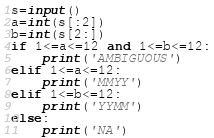Convert code to text. <code><loc_0><loc_0><loc_500><loc_500><_Python_>s=input()
a=int(s[:2])
b=int(s[2:])
if 1<=a<=12 and 1<=b<=12:
    print('AMBIGUOUS')
elif 1<=a<=12:
    print('MMYY')
elif 1<=b<=12:
    print('YYMM')
else:
    print('NA')</code> 